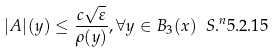Convert formula to latex. <formula><loc_0><loc_0><loc_500><loc_500>| A | ( y ) \leq \frac { c \sqrt { \varepsilon } } { \rho ( y ) } , \forall y \in B _ { 3 } ( x ) \ S . ^ { n } { 5 . 2 . 1 5 }</formula> 